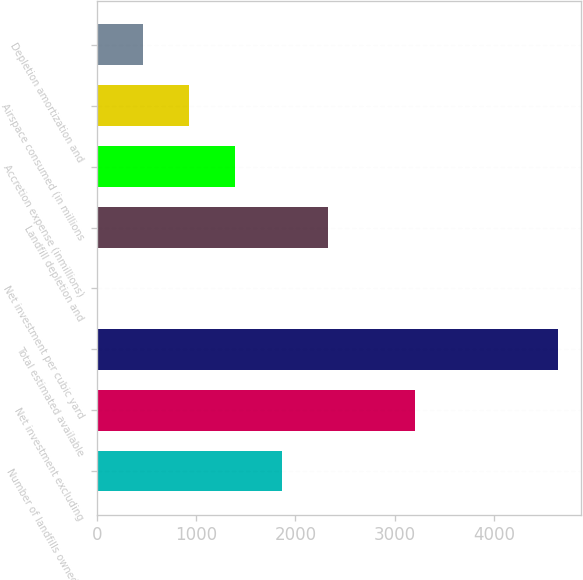Convert chart to OTSL. <chart><loc_0><loc_0><loc_500><loc_500><bar_chart><fcel>Number of landfills owned or<fcel>Net investment excluding<fcel>Total estimated available<fcel>Net investment per cubic yard<fcel>Landfill depletion and<fcel>Accretion expense (inmillions)<fcel>Airspace consumed (in millions<fcel>Depletion amortization and<nl><fcel>1859.97<fcel>3200.6<fcel>4648.9<fcel>0.69<fcel>2324.79<fcel>1395.15<fcel>930.33<fcel>465.51<nl></chart> 